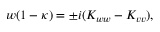<formula> <loc_0><loc_0><loc_500><loc_500>w ( 1 - \kappa ) = \pm i ( K _ { w w } - K _ { v v } ) ,</formula> 